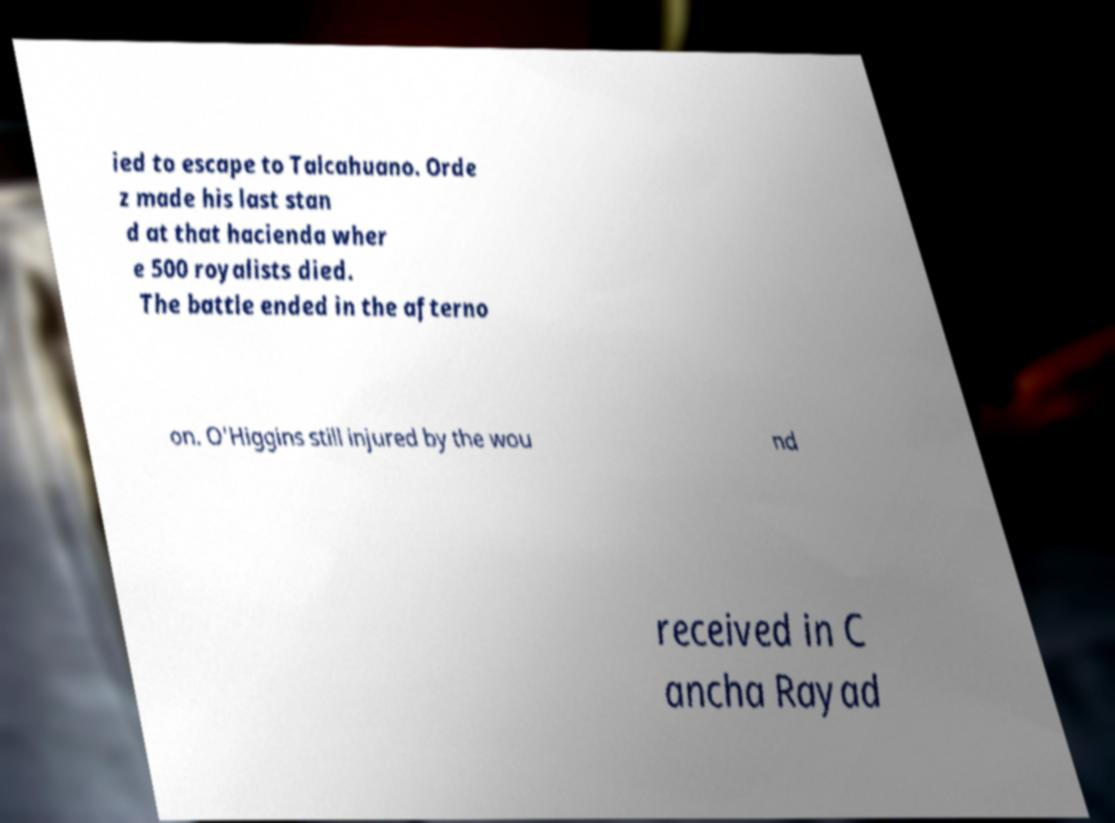Could you extract and type out the text from this image? ied to escape to Talcahuano. Orde z made his last stan d at that hacienda wher e 500 royalists died. The battle ended in the afterno on. O'Higgins still injured by the wou nd received in C ancha Rayad 